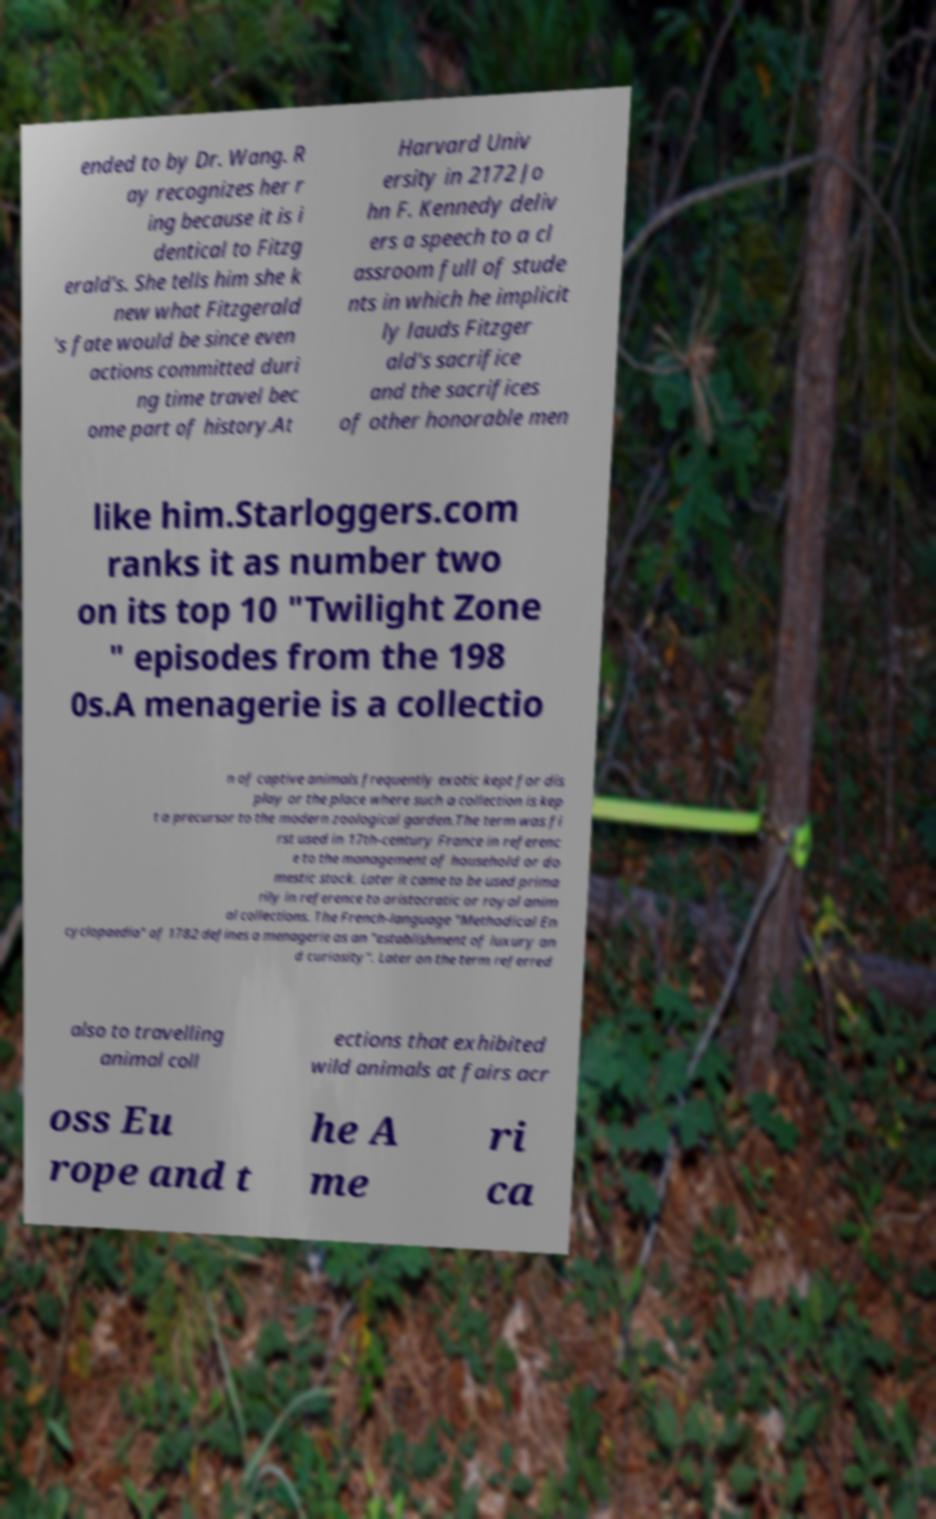I need the written content from this picture converted into text. Can you do that? ended to by Dr. Wang. R ay recognizes her r ing because it is i dentical to Fitzg erald's. She tells him she k new what Fitzgerald 's fate would be since even actions committed duri ng time travel bec ome part of history.At Harvard Univ ersity in 2172 Jo hn F. Kennedy deliv ers a speech to a cl assroom full of stude nts in which he implicit ly lauds Fitzger ald's sacrifice and the sacrifices of other honorable men like him.Starloggers.com ranks it as number two on its top 10 "Twilight Zone " episodes from the 198 0s.A menagerie is a collectio n of captive animals frequently exotic kept for dis play or the place where such a collection is kep t a precursor to the modern zoological garden.The term was fi rst used in 17th-century France in referenc e to the management of household or do mestic stock. Later it came to be used prima rily in reference to aristocratic or royal anim al collections. The French-language "Methodical En cyclopaedia" of 1782 defines a menagerie as an "establishment of luxury an d curiosity". Later on the term referred also to travelling animal coll ections that exhibited wild animals at fairs acr oss Eu rope and t he A me ri ca 